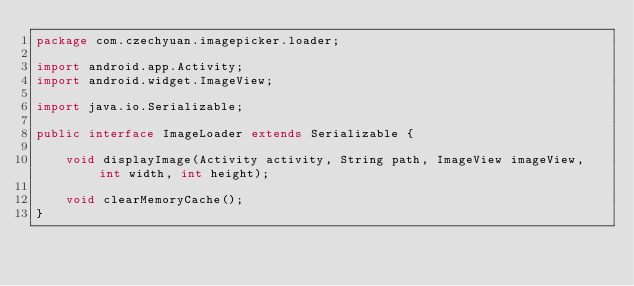Convert code to text. <code><loc_0><loc_0><loc_500><loc_500><_Java_>package com.czechyuan.imagepicker.loader;

import android.app.Activity;
import android.widget.ImageView;

import java.io.Serializable;

public interface ImageLoader extends Serializable {

    void displayImage(Activity activity, String path, ImageView imageView, int width, int height);

    void clearMemoryCache();
}
</code> 